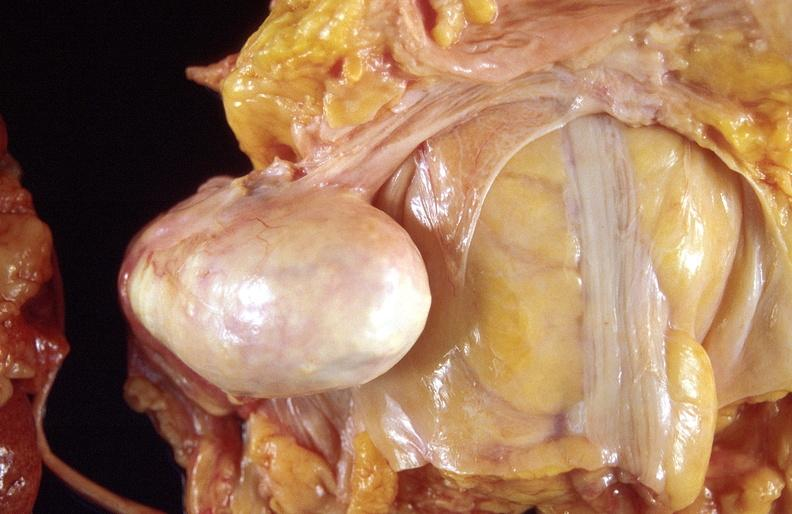does this image show dermoid cyst?
Answer the question using a single word or phrase. Yes 